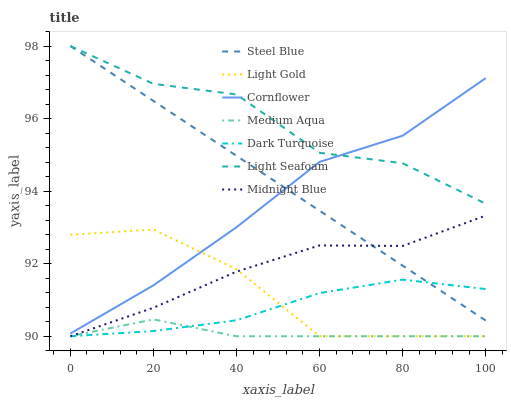Does Medium Aqua have the minimum area under the curve?
Answer yes or no. Yes. Does Light Seafoam have the maximum area under the curve?
Answer yes or no. Yes. Does Midnight Blue have the minimum area under the curve?
Answer yes or no. No. Does Midnight Blue have the maximum area under the curve?
Answer yes or no. No. Is Steel Blue the smoothest?
Answer yes or no. Yes. Is Light Seafoam the roughest?
Answer yes or no. Yes. Is Midnight Blue the smoothest?
Answer yes or no. No. Is Midnight Blue the roughest?
Answer yes or no. No. Does Midnight Blue have the lowest value?
Answer yes or no. Yes. Does Steel Blue have the lowest value?
Answer yes or no. No. Does Light Seafoam have the highest value?
Answer yes or no. Yes. Does Midnight Blue have the highest value?
Answer yes or no. No. Is Dark Turquoise less than Light Seafoam?
Answer yes or no. Yes. Is Cornflower greater than Dark Turquoise?
Answer yes or no. Yes. Does Steel Blue intersect Midnight Blue?
Answer yes or no. Yes. Is Steel Blue less than Midnight Blue?
Answer yes or no. No. Is Steel Blue greater than Midnight Blue?
Answer yes or no. No. Does Dark Turquoise intersect Light Seafoam?
Answer yes or no. No. 